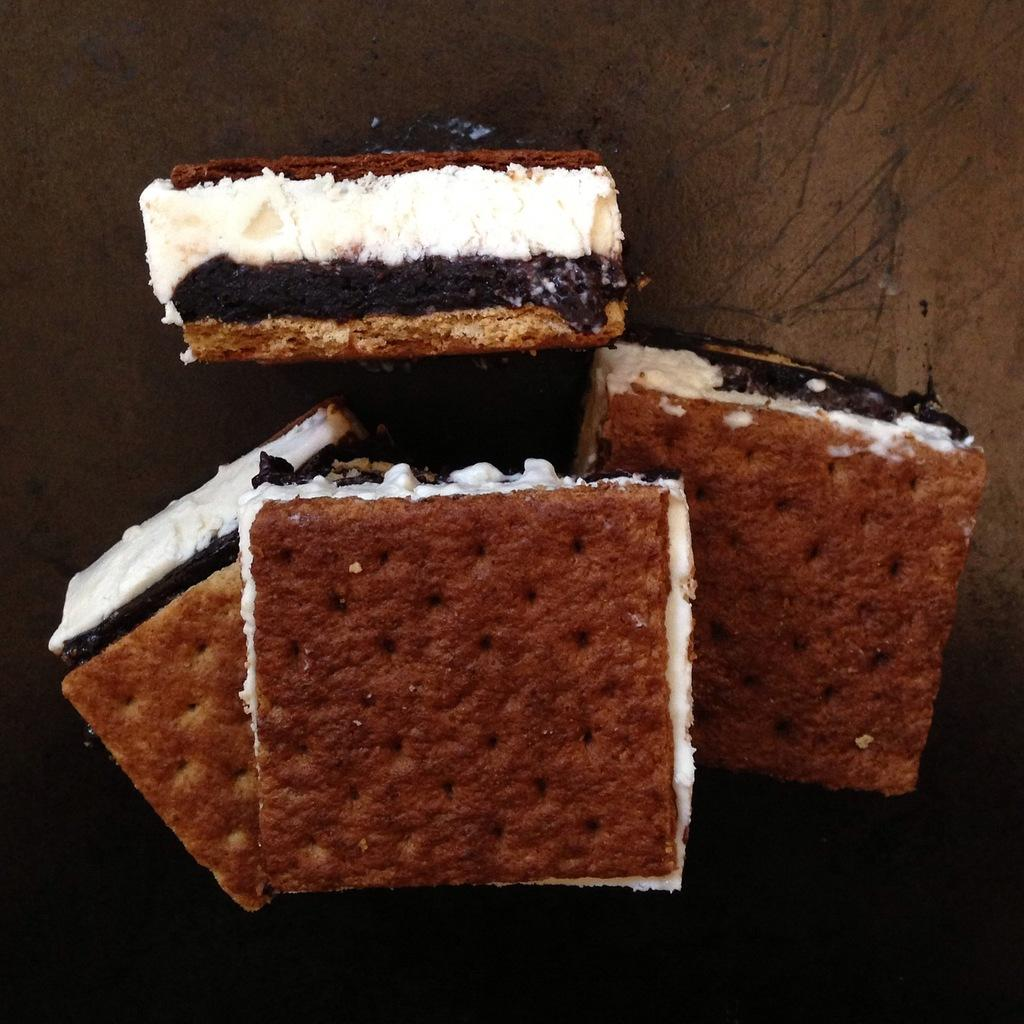What type of food can be seen in the image? There are pieces of cake in the image. Can you describe the appearance of the cake? The provided facts do not include a description of the cake's appearance. How many pieces of cake are visible in the image? The provided facts do not specify the number of cake pieces in the image. What type of caption is written on the vase in the image? There is no vase present in the image, and therefore no caption can be observed. 